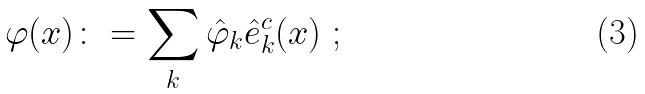Convert formula to latex. <formula><loc_0><loc_0><loc_500><loc_500>\varphi ( x ) \colon = \sum _ { k } \hat { \varphi } _ { k } \hat { e } ^ { c } _ { k } ( x ) \ ;</formula> 